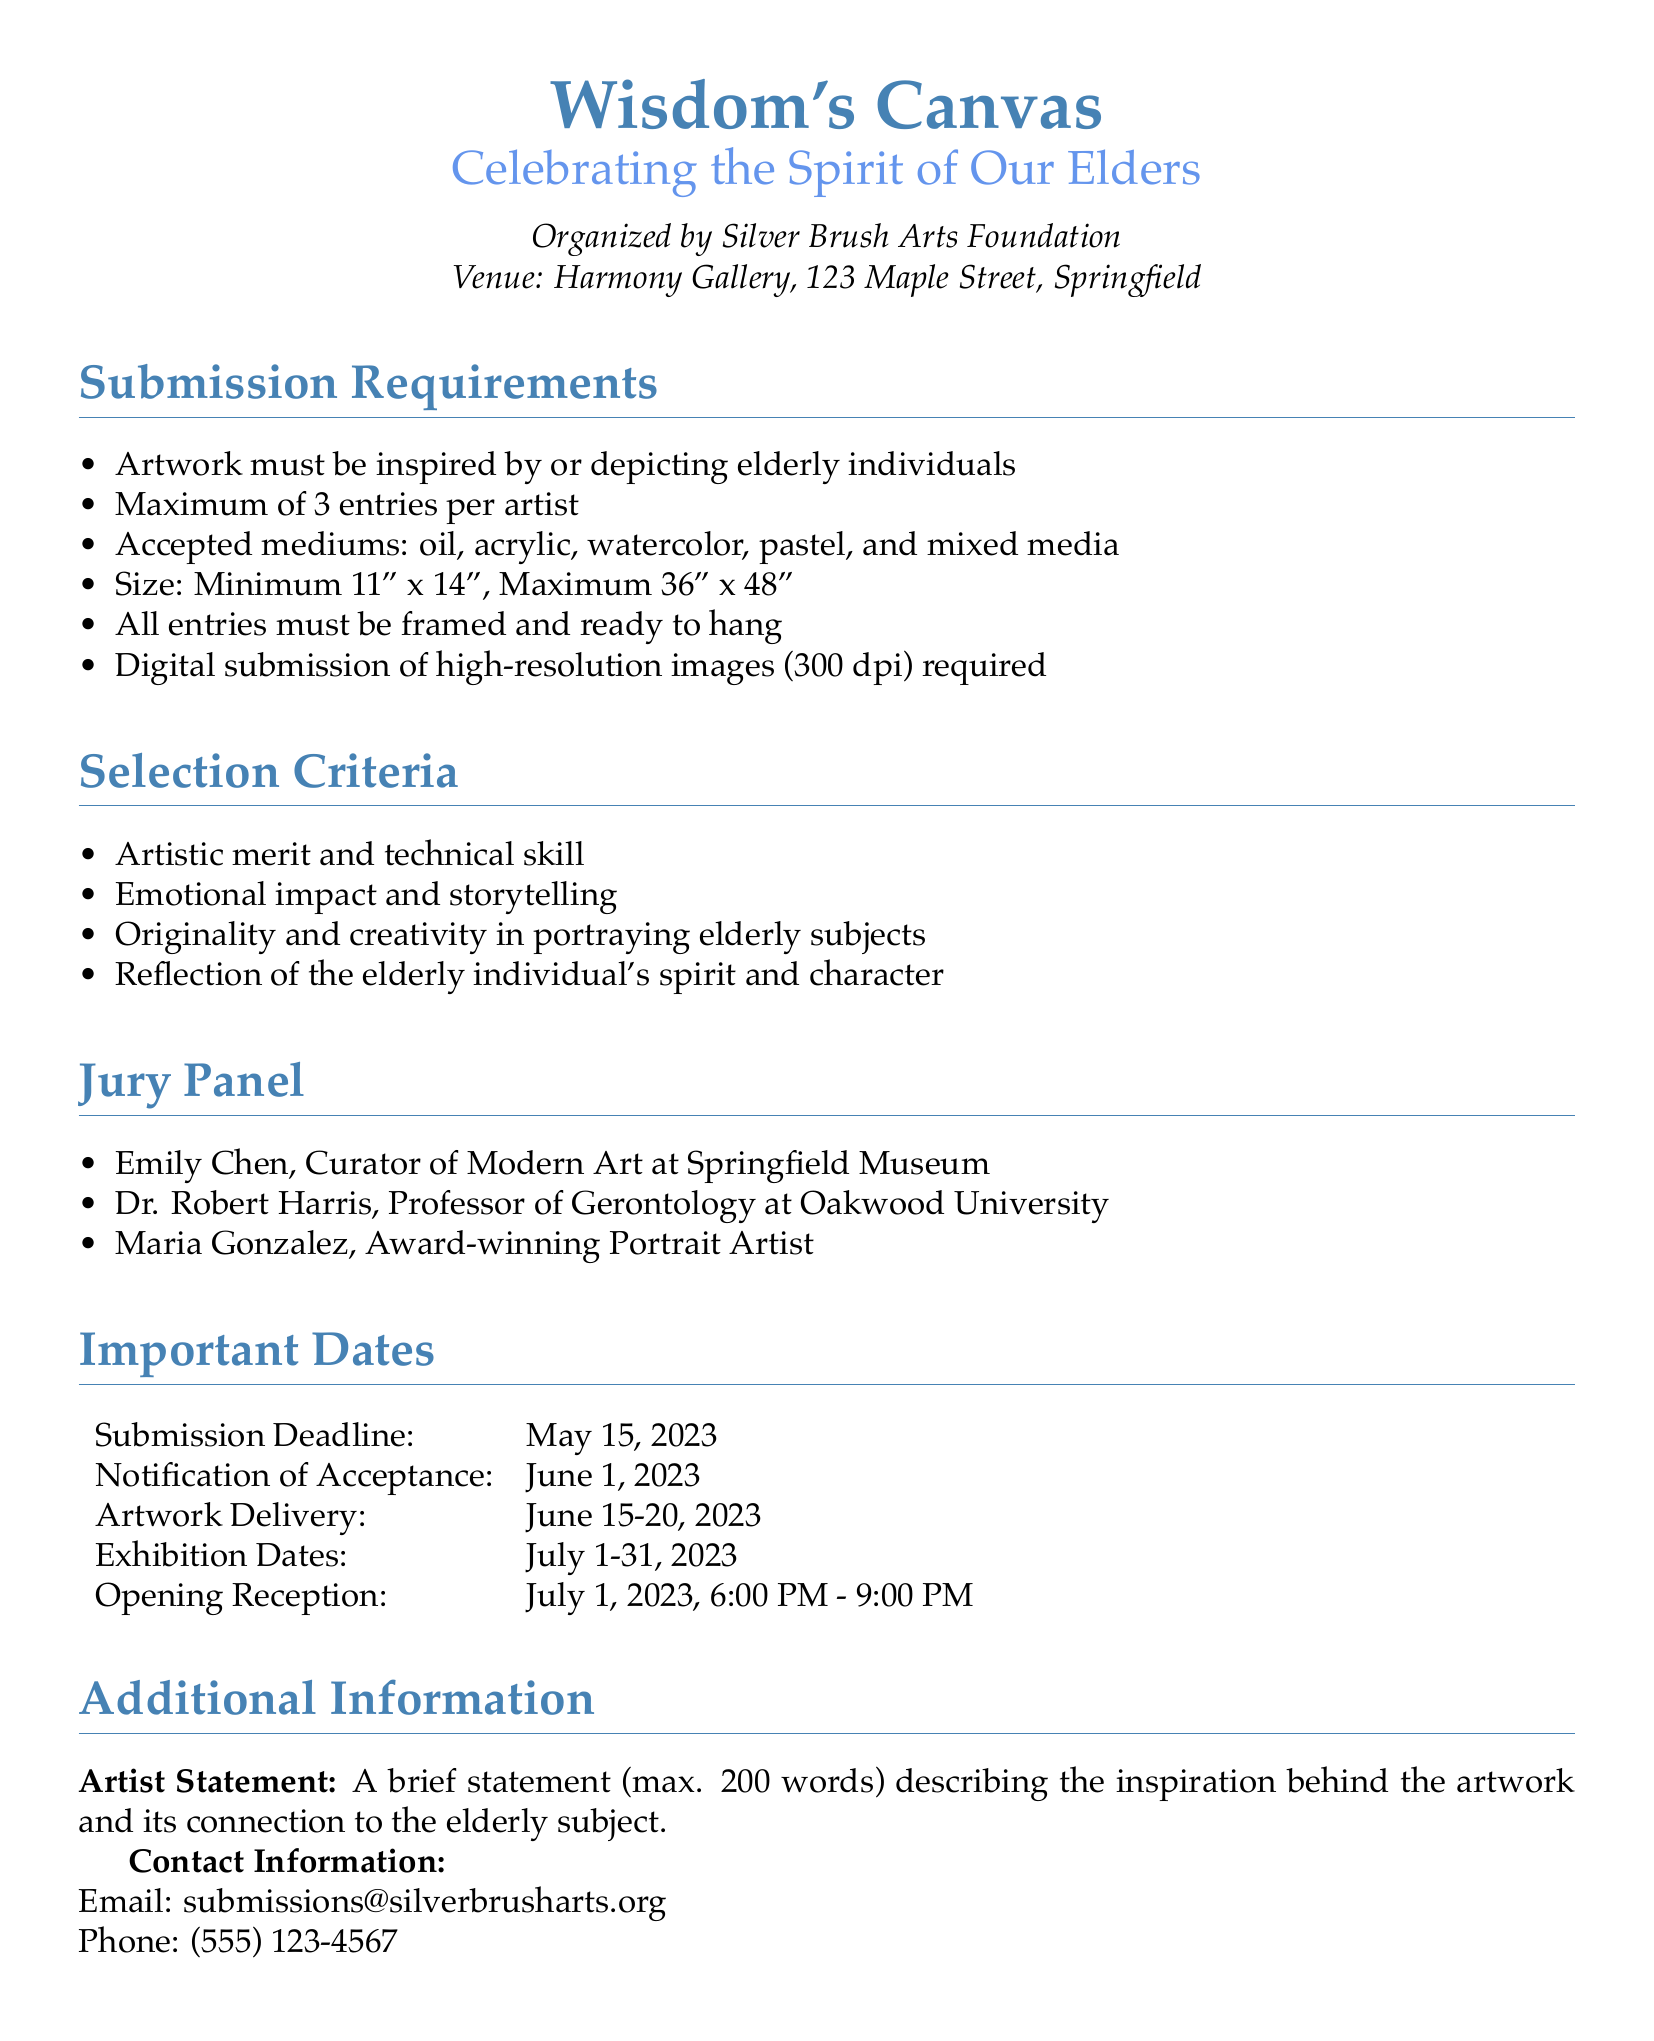What is the title of the exhibition? The title of the exhibition is stated at the top of the document as "Wisdom's Canvas."
Answer: Wisdom's Canvas Who is organizing the exhibition? The organizing body is mentioned in the document as the Silver Brush Arts Foundation.
Answer: Silver Brush Arts Foundation What is the submission deadline? The deadline for submission is indicated in the Important Dates section as May 15, 2023.
Answer: May 15, 2023 How many entries can an artist submit? The document specifies that each artist may submit a maximum of 3 entries.
Answer: 3 entries What is the maximum size for the artwork? The maximum size for the artwork is noted as 36" x 48".
Answer: 36" x 48" What is one of the selection criteria? The criteria for selection includes "Artistic merit and technical skill," among other factors mentioned.
Answer: Artistic merit and technical skill When is the opening reception scheduled? The date for the opening reception is provided in the Important Dates section as July 1, 2023, from 6:00 PM to 9:00 PM.
Answer: July 1, 2023, 6:00 PM - 9:00 PM What must accompany each artwork submission? Each artwork submission requires a digital submission of high-resolution images, as outlined in the submission requirements.
Answer: High-resolution images Who are the jury panel members? The jury panel members are listed as Emily Chen, Dr. Robert Harris, and Maria Gonzalez.
Answer: Emily Chen, Dr. Robert Harris, Maria Gonzalez 